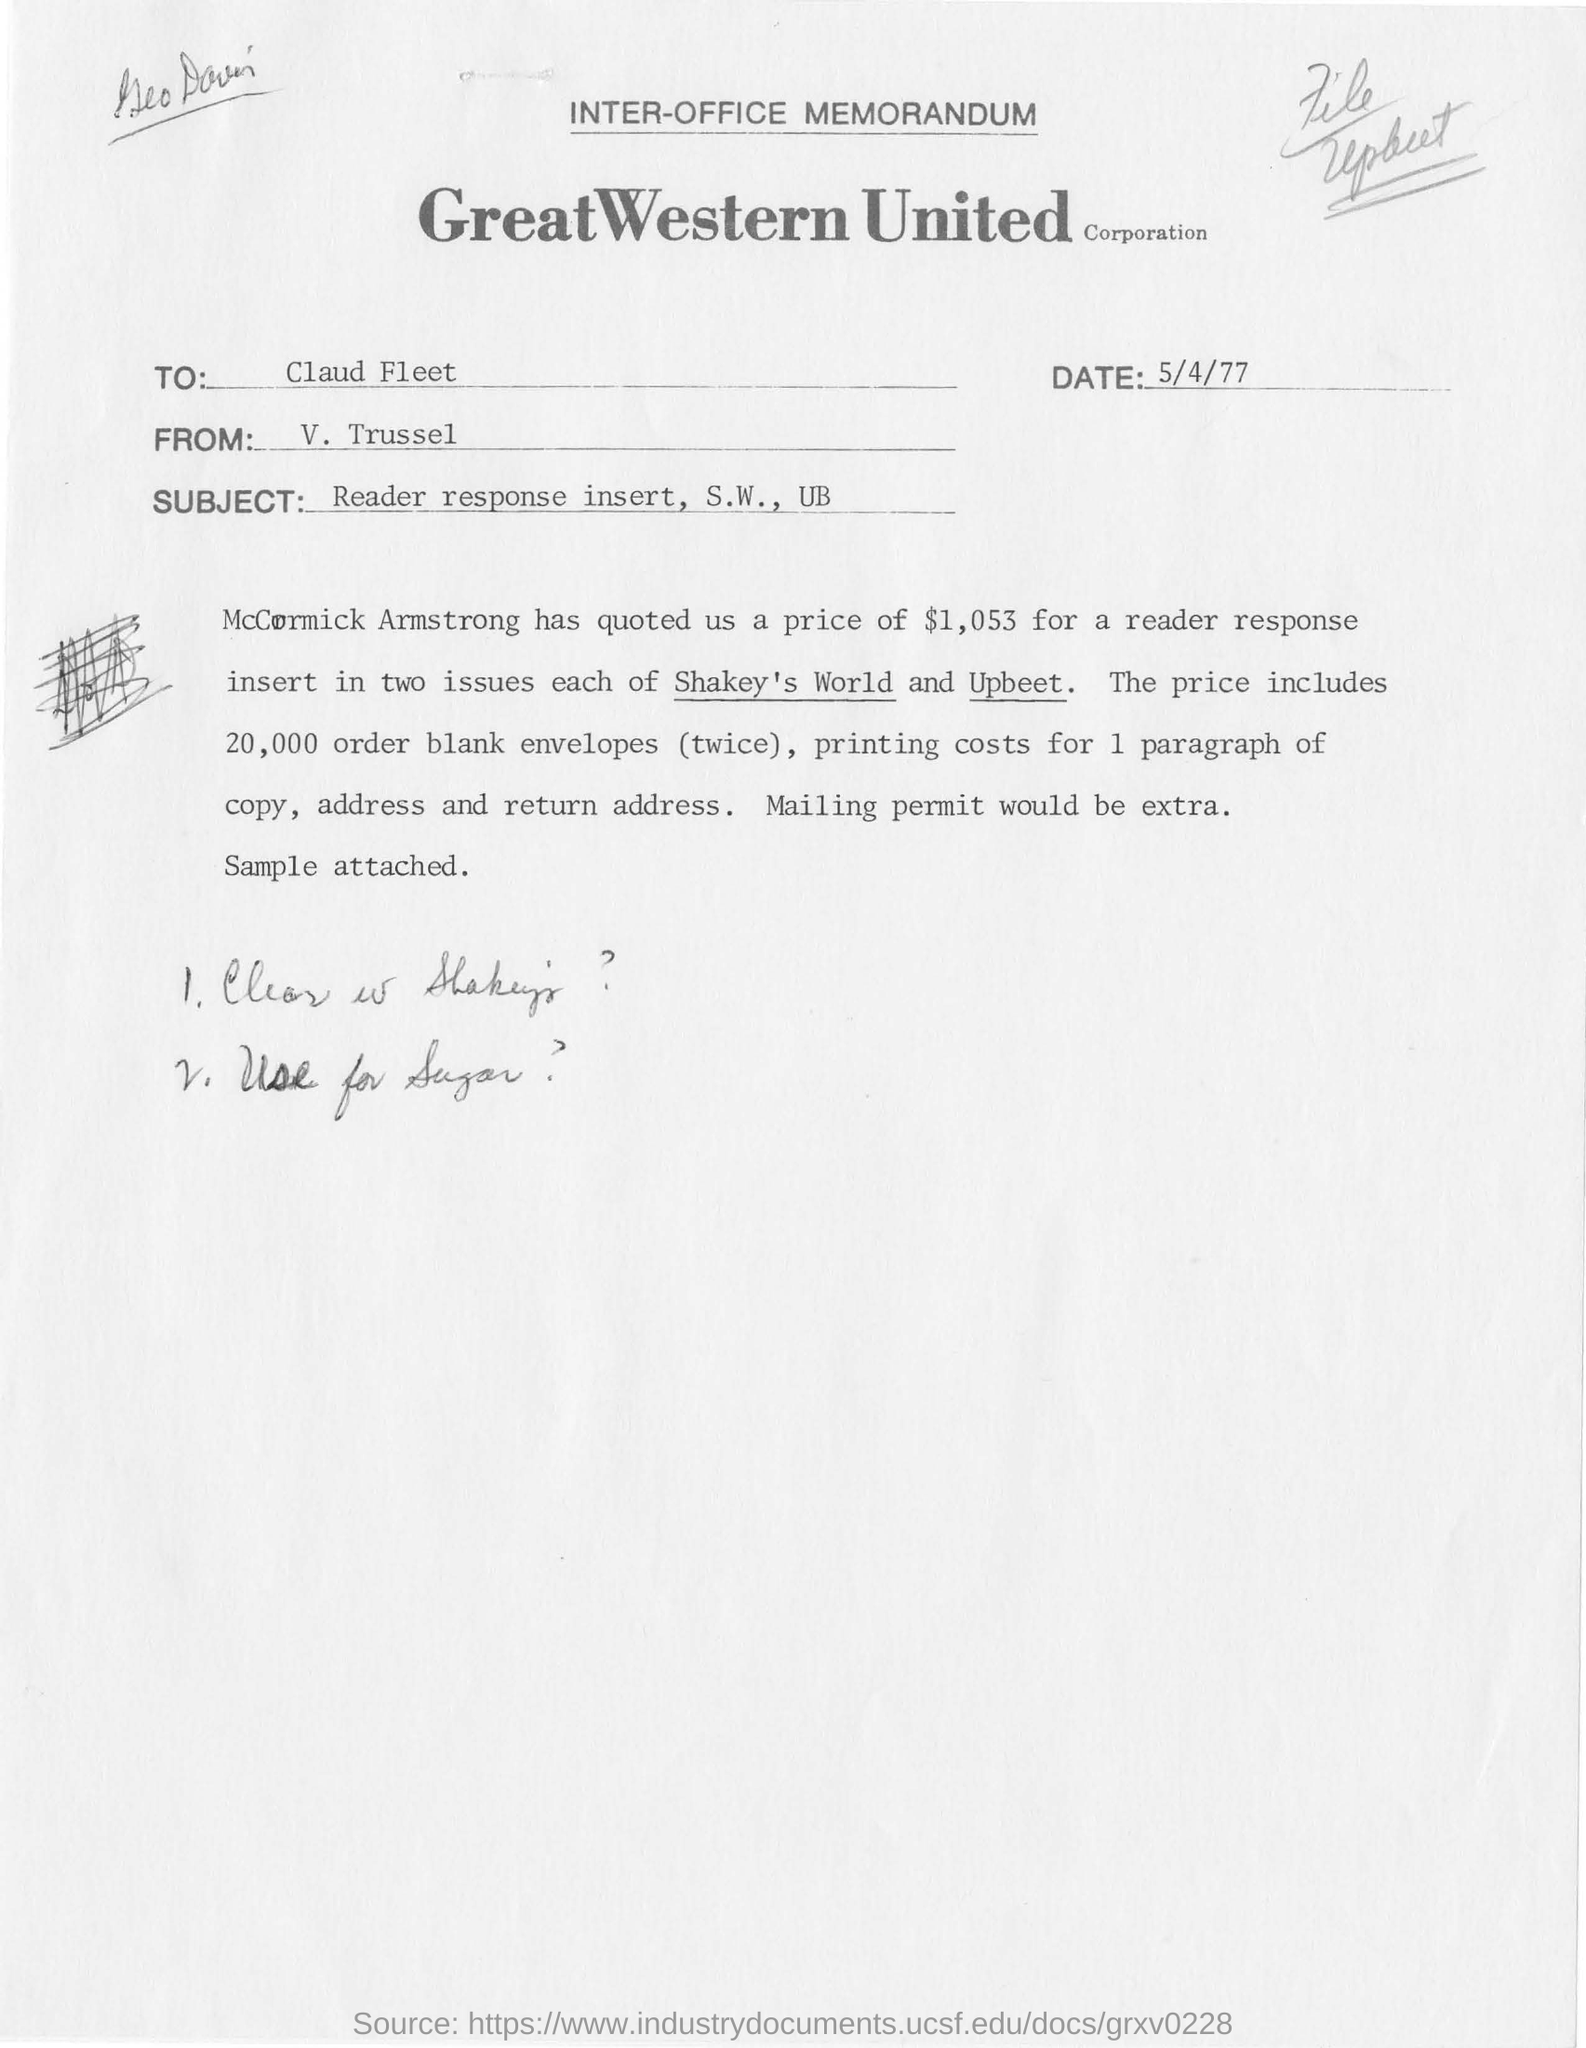Identify some key points in this picture. The subject of the memorandum is mentioned as S.W. and UB. The memorandum mentioned two issues: Shakey's World and Upbeet. The memorandum was written to Claud Fleet. McCormick Armstrong quoted a price of $1,053 for the service provided. On what date was this memorandum written? The memorandum was written on May 4th, 1977. 